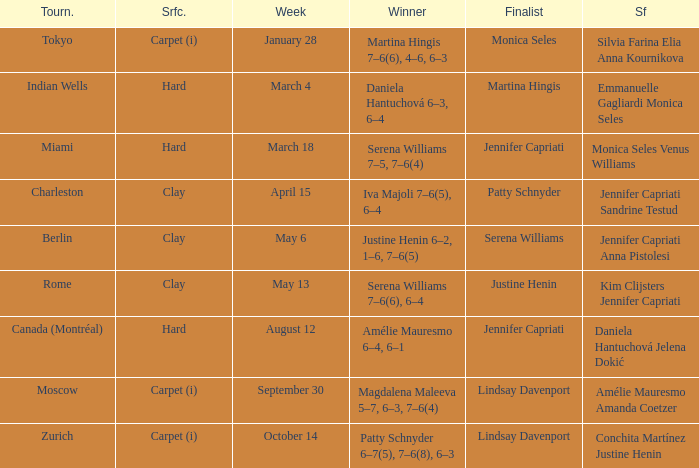Who was the winner in the Indian Wells? Daniela Hantuchová 6–3, 6–4. 